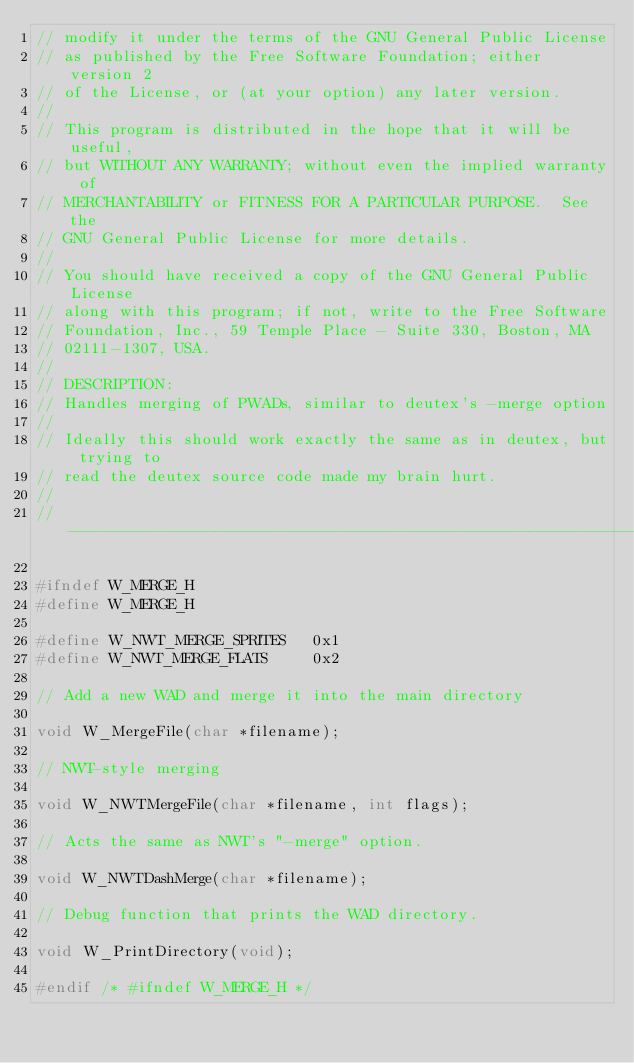<code> <loc_0><loc_0><loc_500><loc_500><_C_>// modify it under the terms of the GNU General Public License
// as published by the Free Software Foundation; either version 2
// of the License, or (at your option) any later version.
//
// This program is distributed in the hope that it will be useful,
// but WITHOUT ANY WARRANTY; without even the implied warranty of
// MERCHANTABILITY or FITNESS FOR A PARTICULAR PURPOSE.  See the
// GNU General Public License for more details.
//
// You should have received a copy of the GNU General Public License
// along with this program; if not, write to the Free Software
// Foundation, Inc., 59 Temple Place - Suite 330, Boston, MA
// 02111-1307, USA.
//
// DESCRIPTION:
// Handles merging of PWADs, similar to deutex's -merge option
//
// Ideally this should work exactly the same as in deutex, but trying to
// read the deutex source code made my brain hurt.
//
//-----------------------------------------------------------------------------

#ifndef W_MERGE_H
#define W_MERGE_H

#define W_NWT_MERGE_SPRITES   0x1
#define W_NWT_MERGE_FLATS     0x2

// Add a new WAD and merge it into the main directory

void W_MergeFile(char *filename);

// NWT-style merging

void W_NWTMergeFile(char *filename, int flags);

// Acts the same as NWT's "-merge" option.

void W_NWTDashMerge(char *filename);

// Debug function that prints the WAD directory.

void W_PrintDirectory(void);

#endif /* #ifndef W_MERGE_H */

</code> 